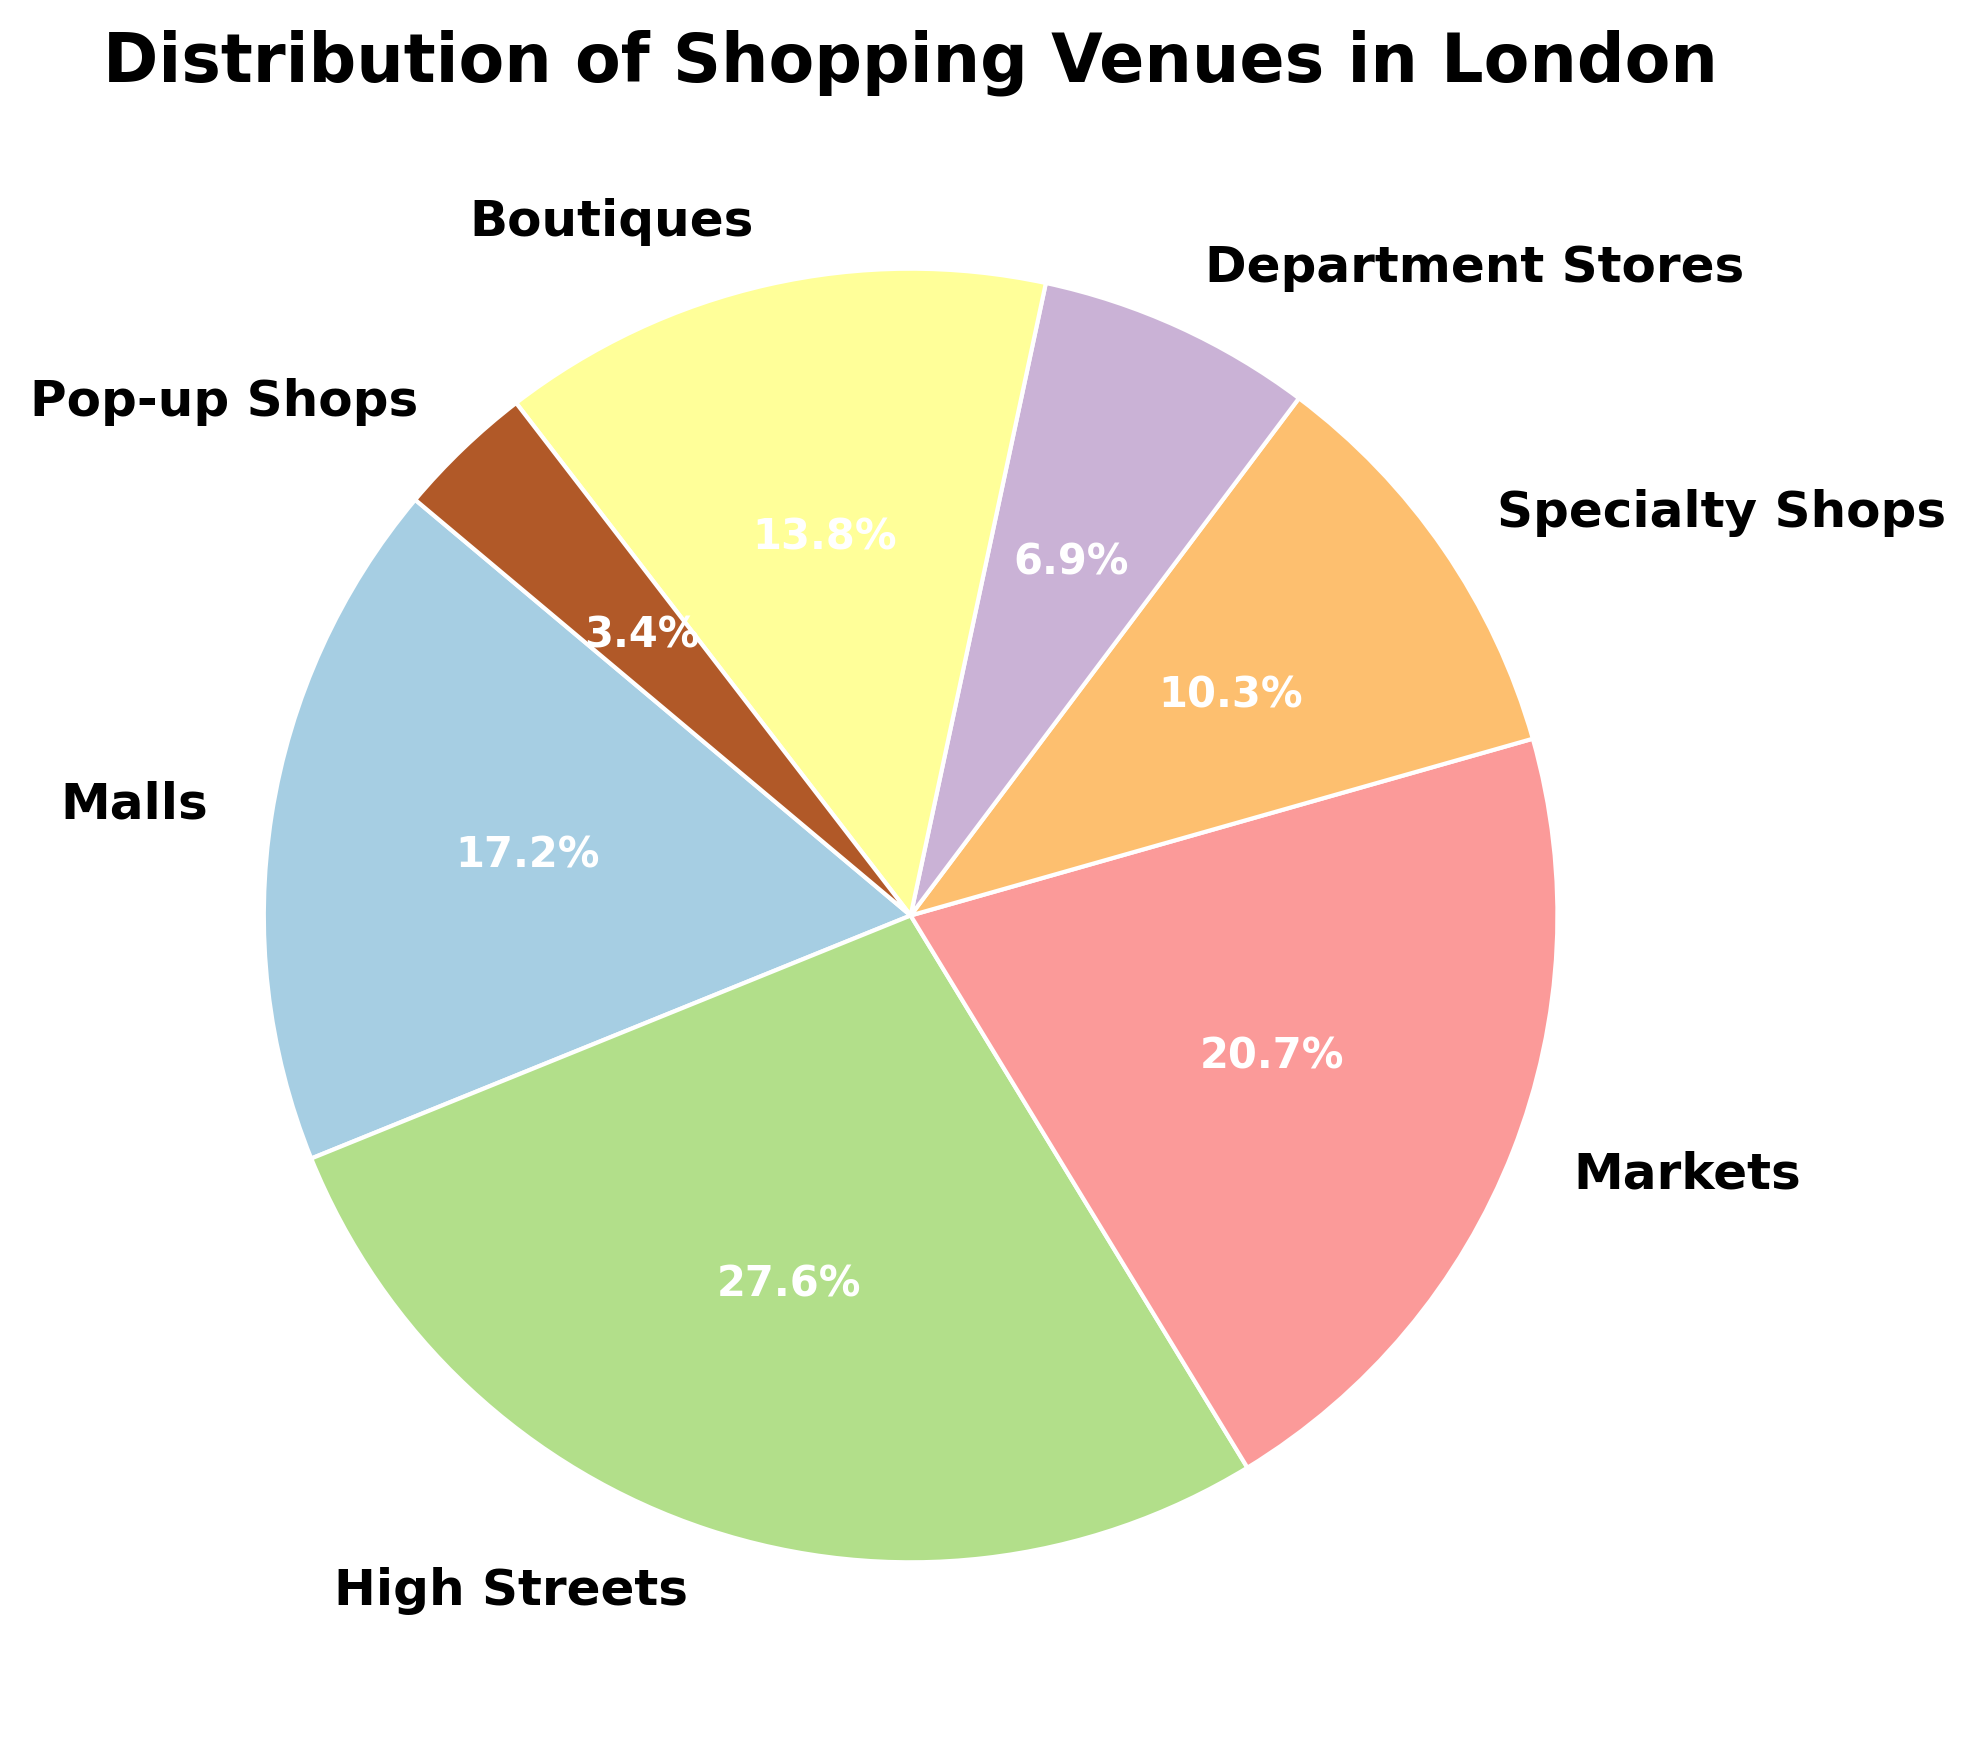How many more High Streets are there compared to Markets? From the figure, we see that there are 40 High Streets and 30 Markets. We subtract the number of Markets from the number of High Streets: 40 - 30 = 10.
Answer: 10 Which venue type is the least common? By comparing the percentages in the pie chart, the slice representing Pop-up Shops is the smallest.
Answer: Pop-up Shops How many venue types have a percentage less than 10%? Examining the pie chart, we see that Specialty Shops, Department Stores, and Pop-up Shops, which all have segments smaller than 10%.
Answer: 3 What is the ratio of Malls to Boutiques? From the chart, there are 25 Malls and 20 Boutiques. The ratio is found by dividing the number of Malls by the number of Boutiques: 25 / 20 = 1.25.
Answer: 1.25 Which venue types have more than 15% of the total venues? Looking at the size of the segments, High Streets and Markets have slices that represent more than 15% of the total venues.
Answer: High Streets, Markets If Specialty Shops and Department Stores are combined, what percentage of the venues do they constitute? Adding the percentages of both types, Specialty Shops (15) and Department Stores (10), gives 15 + 10 = 25. Calculating the total percentage, it becomes (25 / (25+40+30+15+10+20+5)) * 100 = 16.7%.
Answer: 16.7% What color is used to represent Malls, and where is it positioned on the pie chart? The wedge representing Malls is part of the figure's color scheme, often placed towards the starting angle, and color identification can be visually verified. However, without colors, we reference it by location near the start angle.
Answer: Near the start angle Between Boutique and Department Stores, which venue type is larger? Viewing the percentage or slice sizes, we see that Boutiques have a larger segment compared to Department Stores.
Answer: Boutiques If Pop-up Shops doubled in number, how would this affect their percentage in the pie chart? Pop-up Shops currently have 5 venues. Doubling this would make 10 venues. The combined total becomes (145 + 5) = 150. The new percentage is (10 / 150) * 100 = 6.7%.
Answer: 6.7% 